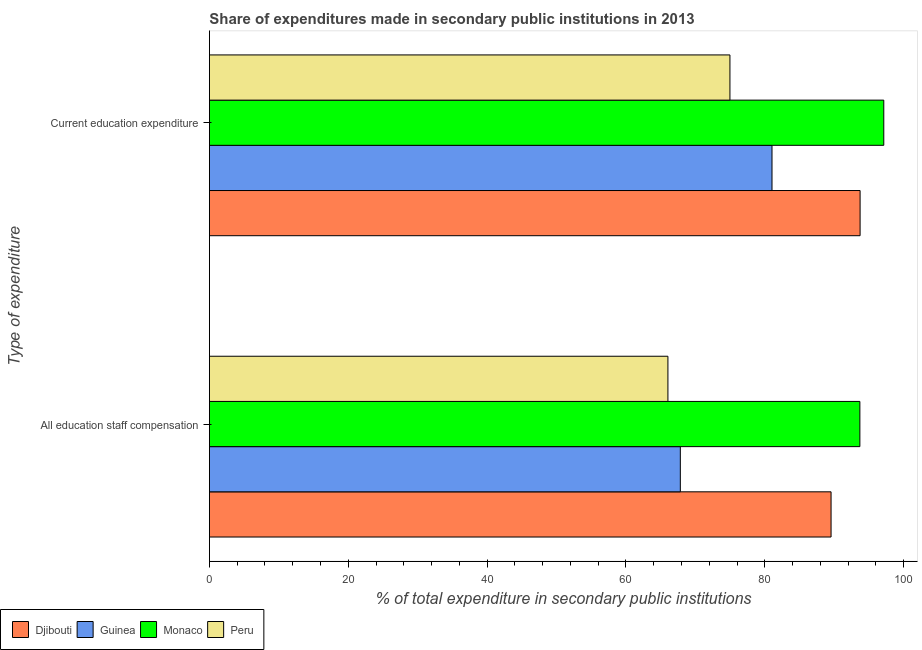How many bars are there on the 2nd tick from the bottom?
Provide a short and direct response. 4. What is the label of the 1st group of bars from the top?
Offer a terse response. Current education expenditure. What is the expenditure in staff compensation in Djibouti?
Ensure brevity in your answer.  89.55. Across all countries, what is the maximum expenditure in staff compensation?
Offer a terse response. 93.7. Across all countries, what is the minimum expenditure in education?
Your answer should be very brief. 74.98. In which country was the expenditure in staff compensation maximum?
Keep it short and to the point. Monaco. In which country was the expenditure in education minimum?
Provide a succinct answer. Peru. What is the total expenditure in education in the graph?
Provide a succinct answer. 346.9. What is the difference between the expenditure in education in Djibouti and that in Guinea?
Your answer should be compact. 12.69. What is the difference between the expenditure in education in Peru and the expenditure in staff compensation in Guinea?
Offer a terse response. 7.15. What is the average expenditure in education per country?
Ensure brevity in your answer.  86.72. What is the difference between the expenditure in education and expenditure in staff compensation in Peru?
Ensure brevity in your answer.  8.93. In how many countries, is the expenditure in staff compensation greater than 68 %?
Provide a succinct answer. 2. What is the ratio of the expenditure in staff compensation in Peru to that in Djibouti?
Make the answer very short. 0.74. Is the expenditure in staff compensation in Monaco less than that in Guinea?
Your answer should be very brief. No. What does the 3rd bar from the top in All education staff compensation represents?
Ensure brevity in your answer.  Guinea. What does the 3rd bar from the bottom in Current education expenditure represents?
Your answer should be very brief. Monaco. How many bars are there?
Keep it short and to the point. 8. Are all the bars in the graph horizontal?
Your answer should be compact. Yes. Does the graph contain grids?
Your answer should be very brief. No. How are the legend labels stacked?
Keep it short and to the point. Horizontal. What is the title of the graph?
Offer a very short reply. Share of expenditures made in secondary public institutions in 2013. Does "Honduras" appear as one of the legend labels in the graph?
Provide a short and direct response. No. What is the label or title of the X-axis?
Provide a succinct answer. % of total expenditure in secondary public institutions. What is the label or title of the Y-axis?
Provide a short and direct response. Type of expenditure. What is the % of total expenditure in secondary public institutions in Djibouti in All education staff compensation?
Give a very brief answer. 89.55. What is the % of total expenditure in secondary public institutions of Guinea in All education staff compensation?
Provide a succinct answer. 67.84. What is the % of total expenditure in secondary public institutions in Monaco in All education staff compensation?
Your response must be concise. 93.7. What is the % of total expenditure in secondary public institutions of Peru in All education staff compensation?
Your response must be concise. 66.05. What is the % of total expenditure in secondary public institutions of Djibouti in Current education expenditure?
Give a very brief answer. 93.73. What is the % of total expenditure in secondary public institutions in Guinea in Current education expenditure?
Keep it short and to the point. 81.04. What is the % of total expenditure in secondary public institutions of Monaco in Current education expenditure?
Your answer should be compact. 97.14. What is the % of total expenditure in secondary public institutions in Peru in Current education expenditure?
Provide a short and direct response. 74.98. Across all Type of expenditure, what is the maximum % of total expenditure in secondary public institutions in Djibouti?
Keep it short and to the point. 93.73. Across all Type of expenditure, what is the maximum % of total expenditure in secondary public institutions of Guinea?
Keep it short and to the point. 81.04. Across all Type of expenditure, what is the maximum % of total expenditure in secondary public institutions of Monaco?
Give a very brief answer. 97.14. Across all Type of expenditure, what is the maximum % of total expenditure in secondary public institutions in Peru?
Provide a succinct answer. 74.98. Across all Type of expenditure, what is the minimum % of total expenditure in secondary public institutions in Djibouti?
Ensure brevity in your answer.  89.55. Across all Type of expenditure, what is the minimum % of total expenditure in secondary public institutions in Guinea?
Offer a terse response. 67.84. Across all Type of expenditure, what is the minimum % of total expenditure in secondary public institutions of Monaco?
Ensure brevity in your answer.  93.7. Across all Type of expenditure, what is the minimum % of total expenditure in secondary public institutions of Peru?
Make the answer very short. 66.05. What is the total % of total expenditure in secondary public institutions in Djibouti in the graph?
Provide a succinct answer. 183.28. What is the total % of total expenditure in secondary public institutions of Guinea in the graph?
Keep it short and to the point. 148.88. What is the total % of total expenditure in secondary public institutions of Monaco in the graph?
Provide a succinct answer. 190.84. What is the total % of total expenditure in secondary public institutions of Peru in the graph?
Your answer should be compact. 141.03. What is the difference between the % of total expenditure in secondary public institutions of Djibouti in All education staff compensation and that in Current education expenditure?
Keep it short and to the point. -4.18. What is the difference between the % of total expenditure in secondary public institutions in Guinea in All education staff compensation and that in Current education expenditure?
Your answer should be compact. -13.21. What is the difference between the % of total expenditure in secondary public institutions in Monaco in All education staff compensation and that in Current education expenditure?
Offer a very short reply. -3.44. What is the difference between the % of total expenditure in secondary public institutions of Peru in All education staff compensation and that in Current education expenditure?
Offer a terse response. -8.93. What is the difference between the % of total expenditure in secondary public institutions in Djibouti in All education staff compensation and the % of total expenditure in secondary public institutions in Guinea in Current education expenditure?
Keep it short and to the point. 8.51. What is the difference between the % of total expenditure in secondary public institutions in Djibouti in All education staff compensation and the % of total expenditure in secondary public institutions in Monaco in Current education expenditure?
Provide a short and direct response. -7.59. What is the difference between the % of total expenditure in secondary public institutions in Djibouti in All education staff compensation and the % of total expenditure in secondary public institutions in Peru in Current education expenditure?
Your response must be concise. 14.57. What is the difference between the % of total expenditure in secondary public institutions of Guinea in All education staff compensation and the % of total expenditure in secondary public institutions of Monaco in Current education expenditure?
Offer a very short reply. -29.31. What is the difference between the % of total expenditure in secondary public institutions of Guinea in All education staff compensation and the % of total expenditure in secondary public institutions of Peru in Current education expenditure?
Provide a short and direct response. -7.15. What is the difference between the % of total expenditure in secondary public institutions in Monaco in All education staff compensation and the % of total expenditure in secondary public institutions in Peru in Current education expenditure?
Keep it short and to the point. 18.72. What is the average % of total expenditure in secondary public institutions in Djibouti per Type of expenditure?
Give a very brief answer. 91.64. What is the average % of total expenditure in secondary public institutions of Guinea per Type of expenditure?
Make the answer very short. 74.44. What is the average % of total expenditure in secondary public institutions in Monaco per Type of expenditure?
Give a very brief answer. 95.42. What is the average % of total expenditure in secondary public institutions in Peru per Type of expenditure?
Ensure brevity in your answer.  70.52. What is the difference between the % of total expenditure in secondary public institutions in Djibouti and % of total expenditure in secondary public institutions in Guinea in All education staff compensation?
Your response must be concise. 21.71. What is the difference between the % of total expenditure in secondary public institutions of Djibouti and % of total expenditure in secondary public institutions of Monaco in All education staff compensation?
Offer a very short reply. -4.15. What is the difference between the % of total expenditure in secondary public institutions in Djibouti and % of total expenditure in secondary public institutions in Peru in All education staff compensation?
Your response must be concise. 23.5. What is the difference between the % of total expenditure in secondary public institutions in Guinea and % of total expenditure in secondary public institutions in Monaco in All education staff compensation?
Provide a short and direct response. -25.86. What is the difference between the % of total expenditure in secondary public institutions in Guinea and % of total expenditure in secondary public institutions in Peru in All education staff compensation?
Offer a terse response. 1.79. What is the difference between the % of total expenditure in secondary public institutions in Monaco and % of total expenditure in secondary public institutions in Peru in All education staff compensation?
Offer a very short reply. 27.65. What is the difference between the % of total expenditure in secondary public institutions in Djibouti and % of total expenditure in secondary public institutions in Guinea in Current education expenditure?
Keep it short and to the point. 12.69. What is the difference between the % of total expenditure in secondary public institutions in Djibouti and % of total expenditure in secondary public institutions in Monaco in Current education expenditure?
Offer a very short reply. -3.41. What is the difference between the % of total expenditure in secondary public institutions of Djibouti and % of total expenditure in secondary public institutions of Peru in Current education expenditure?
Your answer should be very brief. 18.75. What is the difference between the % of total expenditure in secondary public institutions in Guinea and % of total expenditure in secondary public institutions in Monaco in Current education expenditure?
Offer a terse response. -16.1. What is the difference between the % of total expenditure in secondary public institutions of Guinea and % of total expenditure in secondary public institutions of Peru in Current education expenditure?
Ensure brevity in your answer.  6.06. What is the difference between the % of total expenditure in secondary public institutions of Monaco and % of total expenditure in secondary public institutions of Peru in Current education expenditure?
Give a very brief answer. 22.16. What is the ratio of the % of total expenditure in secondary public institutions in Djibouti in All education staff compensation to that in Current education expenditure?
Offer a very short reply. 0.96. What is the ratio of the % of total expenditure in secondary public institutions in Guinea in All education staff compensation to that in Current education expenditure?
Ensure brevity in your answer.  0.84. What is the ratio of the % of total expenditure in secondary public institutions in Monaco in All education staff compensation to that in Current education expenditure?
Offer a very short reply. 0.96. What is the ratio of the % of total expenditure in secondary public institutions of Peru in All education staff compensation to that in Current education expenditure?
Your answer should be compact. 0.88. What is the difference between the highest and the second highest % of total expenditure in secondary public institutions in Djibouti?
Offer a terse response. 4.18. What is the difference between the highest and the second highest % of total expenditure in secondary public institutions in Guinea?
Provide a succinct answer. 13.21. What is the difference between the highest and the second highest % of total expenditure in secondary public institutions in Monaco?
Your response must be concise. 3.44. What is the difference between the highest and the second highest % of total expenditure in secondary public institutions in Peru?
Give a very brief answer. 8.93. What is the difference between the highest and the lowest % of total expenditure in secondary public institutions of Djibouti?
Provide a short and direct response. 4.18. What is the difference between the highest and the lowest % of total expenditure in secondary public institutions in Guinea?
Your answer should be very brief. 13.21. What is the difference between the highest and the lowest % of total expenditure in secondary public institutions of Monaco?
Provide a succinct answer. 3.44. What is the difference between the highest and the lowest % of total expenditure in secondary public institutions of Peru?
Your answer should be compact. 8.93. 